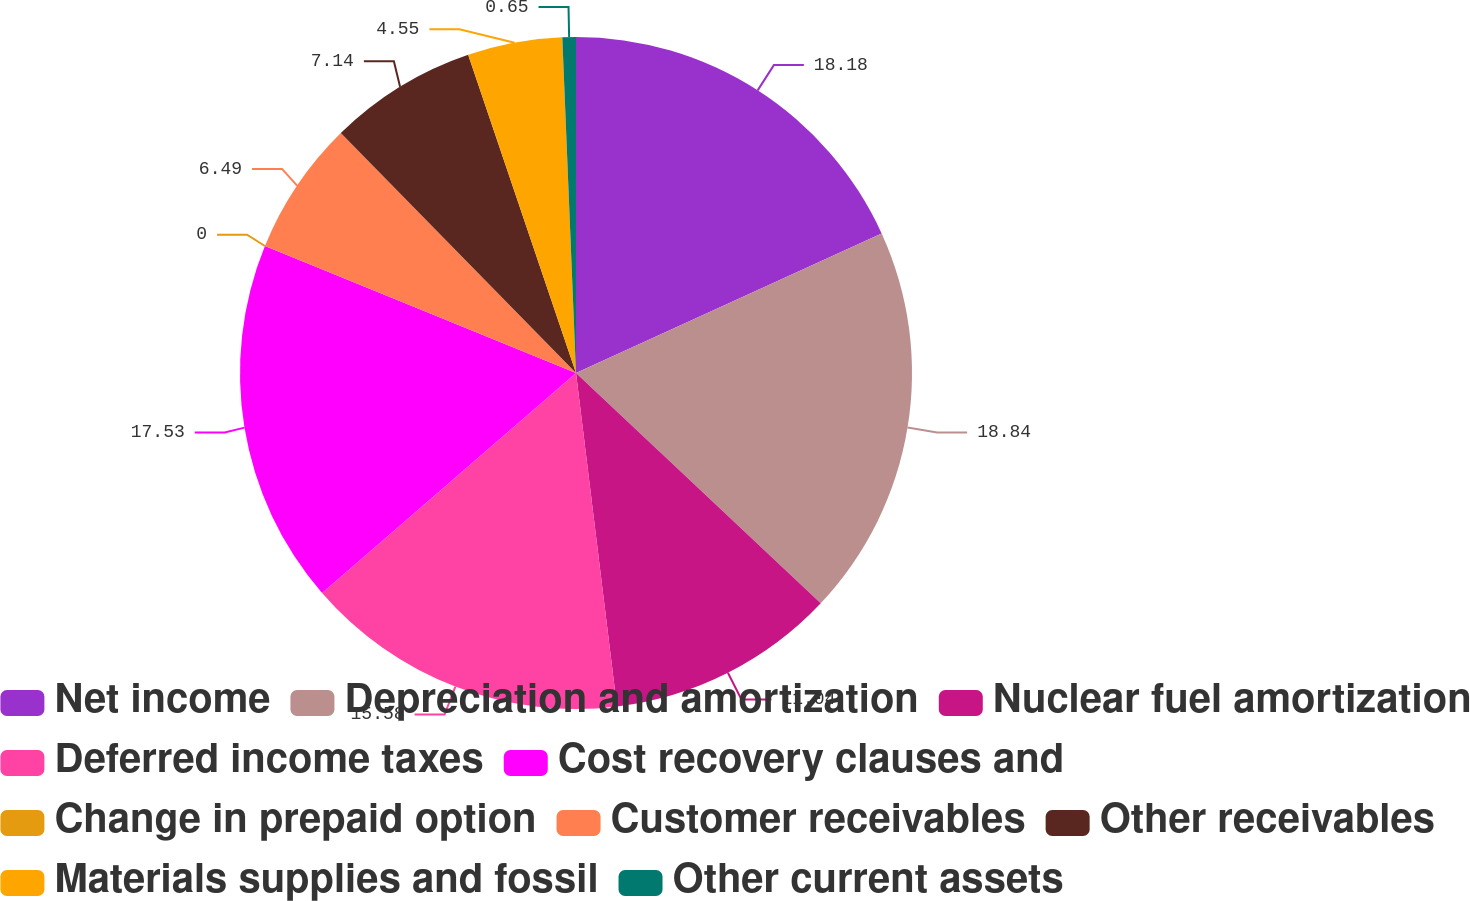Convert chart to OTSL. <chart><loc_0><loc_0><loc_500><loc_500><pie_chart><fcel>Net income<fcel>Depreciation and amortization<fcel>Nuclear fuel amortization<fcel>Deferred income taxes<fcel>Cost recovery clauses and<fcel>Change in prepaid option<fcel>Customer receivables<fcel>Other receivables<fcel>Materials supplies and fossil<fcel>Other current assets<nl><fcel>18.18%<fcel>18.83%<fcel>11.04%<fcel>15.58%<fcel>17.53%<fcel>0.0%<fcel>6.49%<fcel>7.14%<fcel>4.55%<fcel>0.65%<nl></chart> 